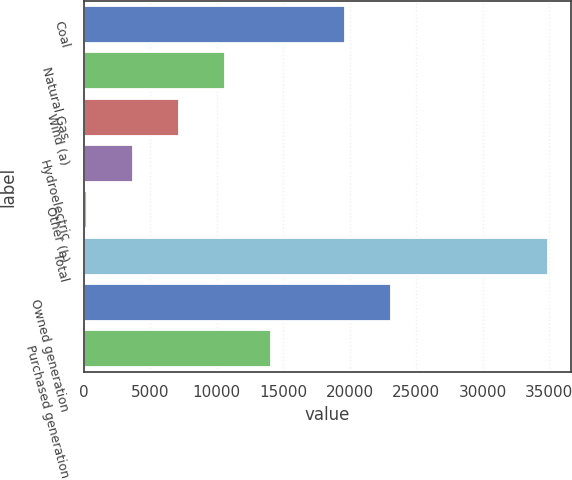Convert chart to OTSL. <chart><loc_0><loc_0><loc_500><loc_500><bar_chart><fcel>Coal<fcel>Natural Gas<fcel>Wind (a)<fcel>Hydroelectric<fcel>Other (b)<fcel>Total<fcel>Owned generation<fcel>Purchased generation<nl><fcel>19647<fcel>10635.1<fcel>7173.4<fcel>3711.7<fcel>250<fcel>34867<fcel>23108.7<fcel>14096.8<nl></chart> 